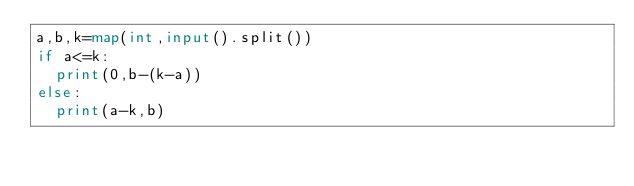<code> <loc_0><loc_0><loc_500><loc_500><_Python_>a,b,k=map(int,input().split())
if a<=k:
  print(0,b-(k-a))
else:
  print(a-k,b)</code> 